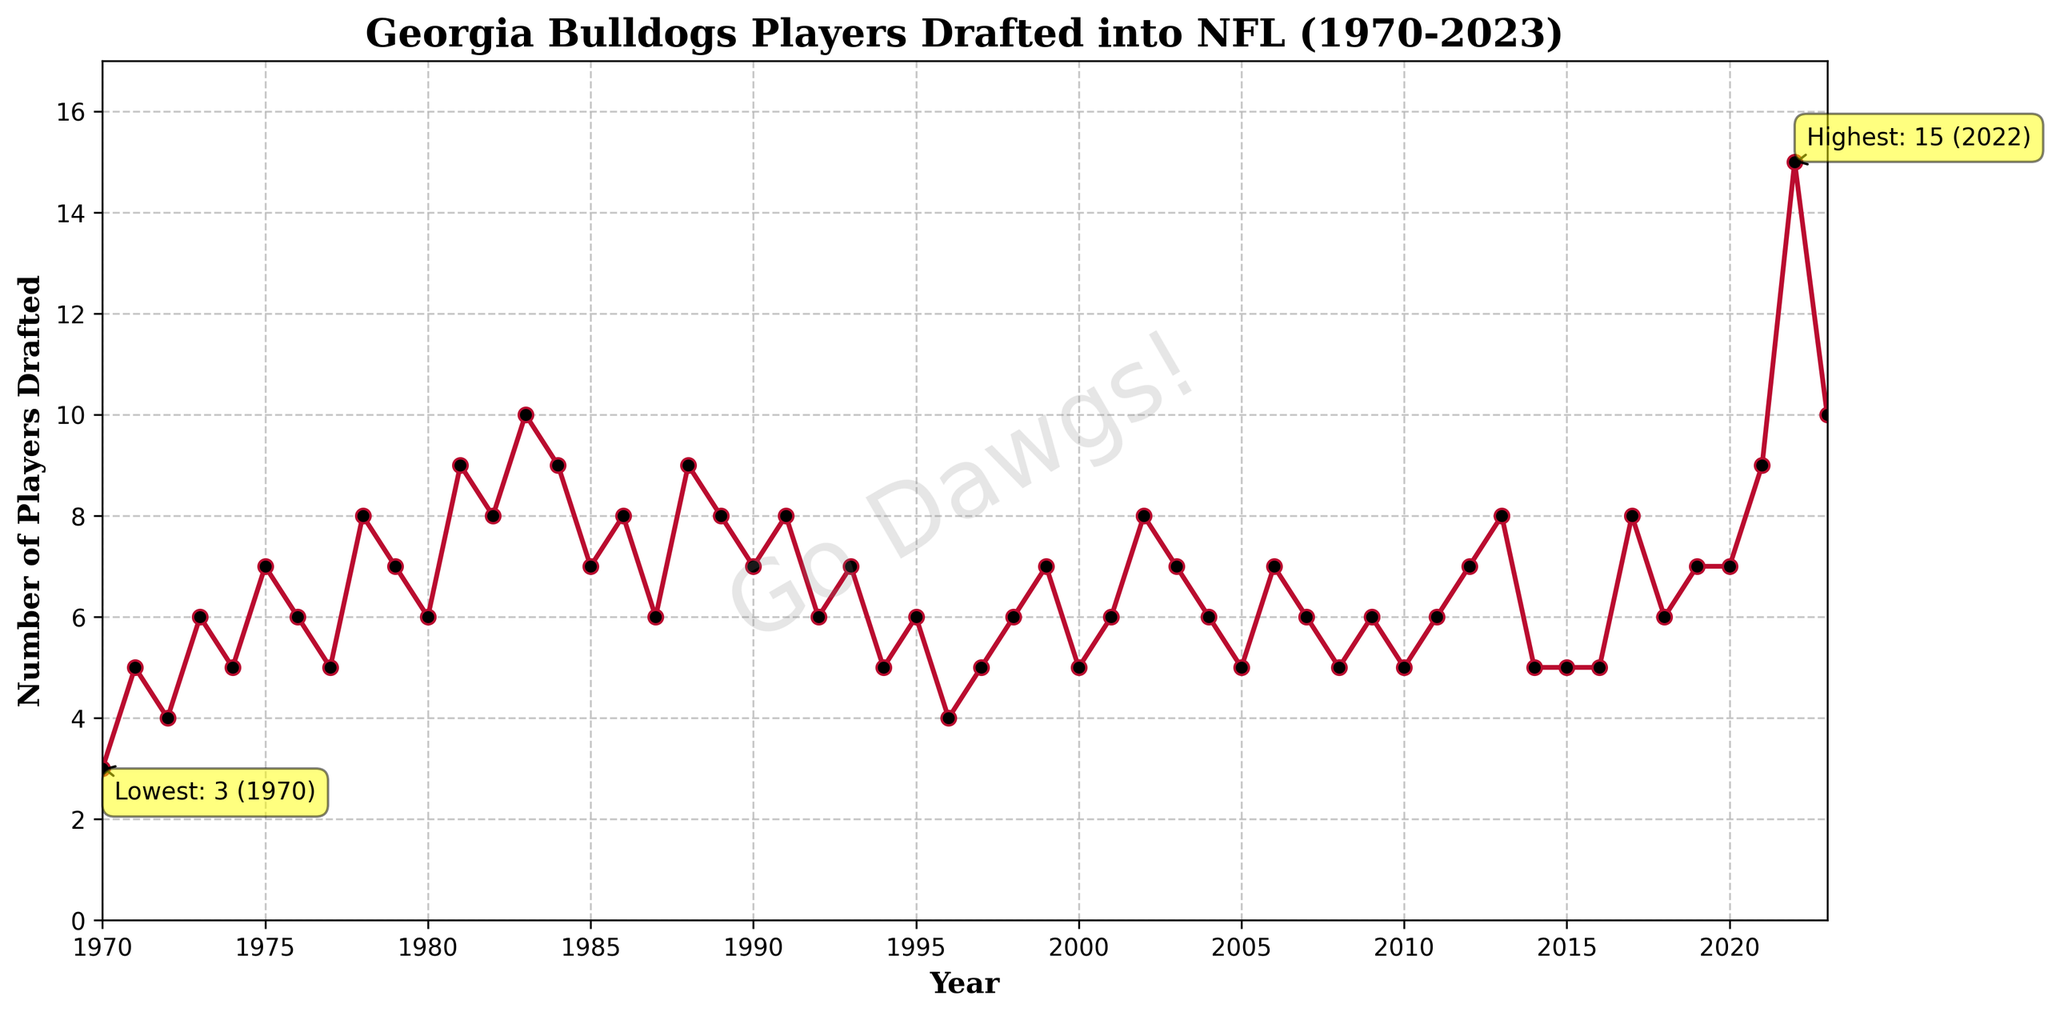What's the highest number of Georgia Bulldogs players drafted in a single year? Look for the highest peak on the line chart. The annotation also points out the highest value.
Answer: 15 What's the lowest number of Georgia Bulldogs players drafted in a single year? Look for the lowest valley on the line chart. The annotation highlights the lowest value as well.
Answer: 3 How many years had exactly 8 players drafted? Identify all the points on the line chart where the value is 8, count these instances.
Answer: 6 What is the average number of players drafted per year from 1980 to 1990? Calculate the sum of players drafted from 1980 to 1990 and divide by the number of years (11).
Answer: 7.5 How does the number of players drafted in 2022 compare to the number in 2020? Check the points for the values in 2022 and 2020, then compare them.
Answer: 2022 had more What trend do you observe from 1970 to 1981? Observe the changes in the number of players drafted from the start year to 1981. The overall trend is noted by the progression of the line.
Answer: Increasing What is the difference between the number of players drafted in the years with the highest and lowest drafts? Use the peak value and the valley value identified earlier, then subtract the smaller number from the larger one.
Answer: 12 In which decade were the Georgia Bulldogs most consistently drafted? Compare the consistency in the number of players drafted each decade by observing the uniformity of the line segments within each decade.
Answer: 1980s What is the median value of players drafted from 2000 to 2010? Sort the number of players drafted from 2000 to 2010, then find the middle value. For an odd number of entries, it is the middle one; for an even number, it is the average of the two middle values.
Answer: 6 Which year had more players drafted, 1990 or 2000? Compare the points on the line chart for the years 1990 and 2000.
Answer: 1990 